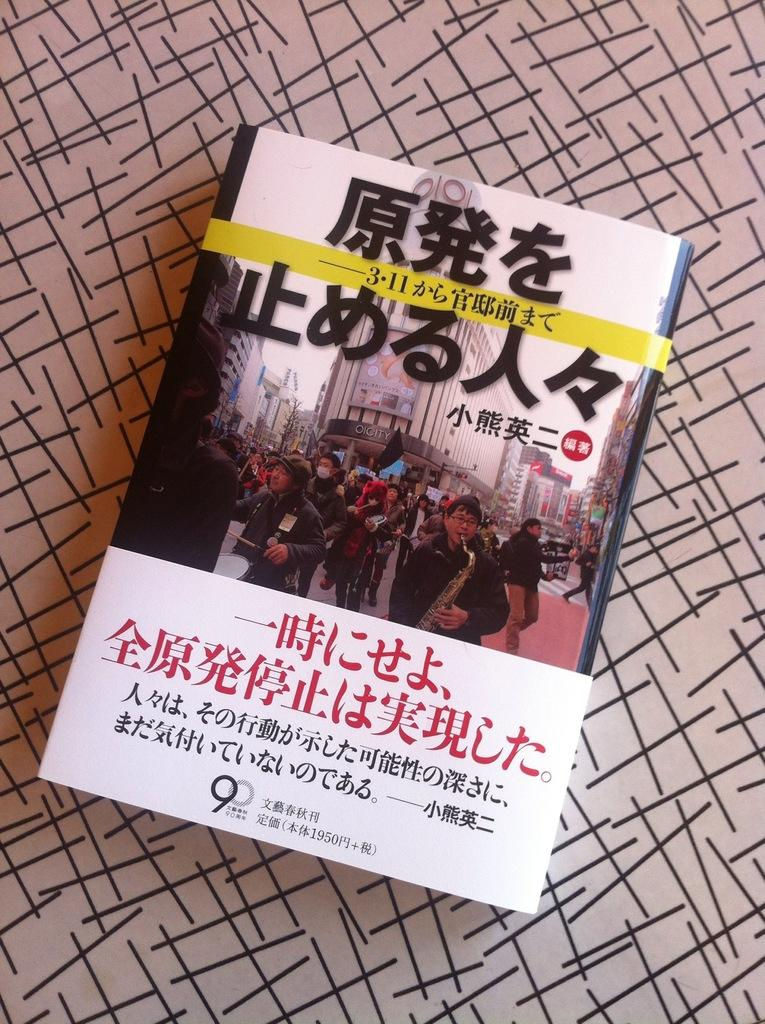What type of book is in the image? There is a foreign language book in the image. Where is the book located in the image? The book is kept on a table in the image. How many gloves are on the table next to the book in the image? There are no gloves present in the image. 